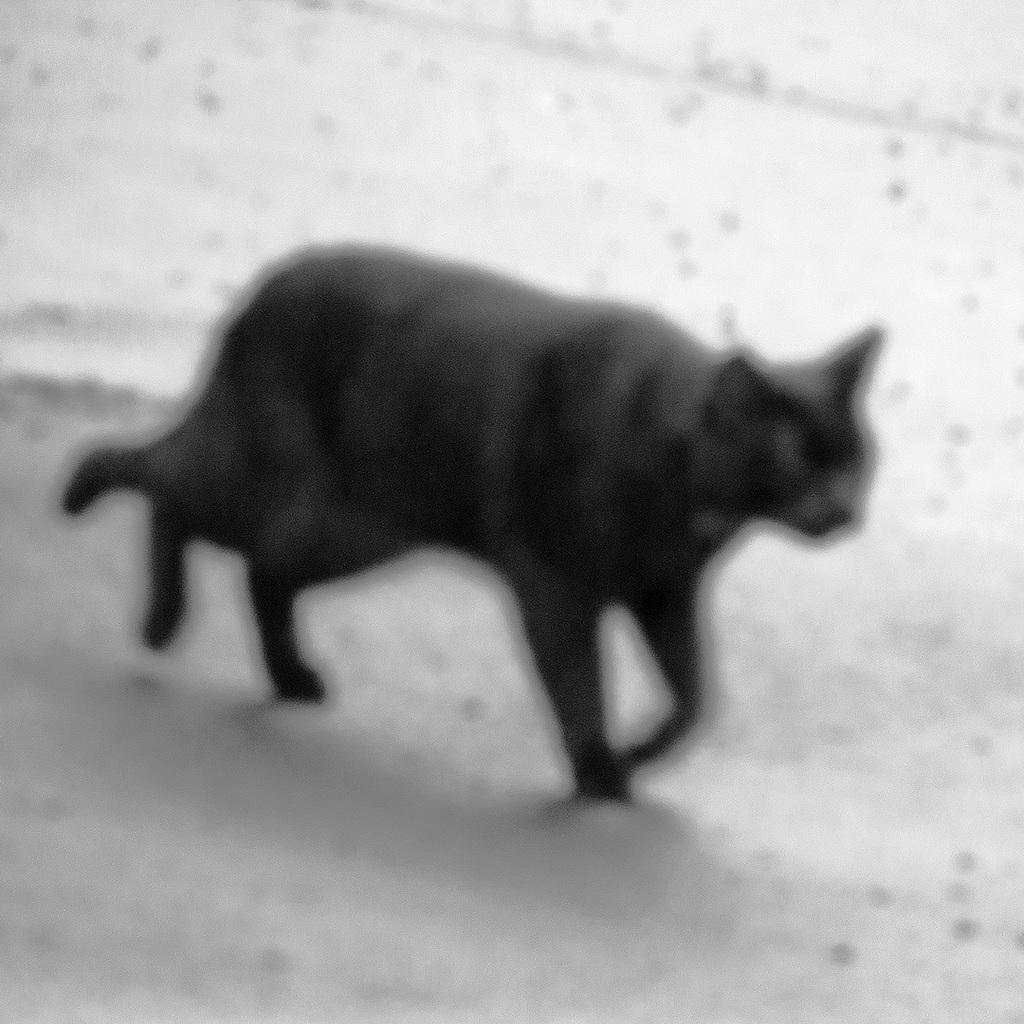What type of animal is in the image? There is a black cat in the image. What direction is the cat moving in? The cat is moving towards the right. What type of pencil can be seen on the floor in the image? There is no pencil present in the image. How many houses are visible in the image? There are no houses visible in the image; it only features a black cat. 